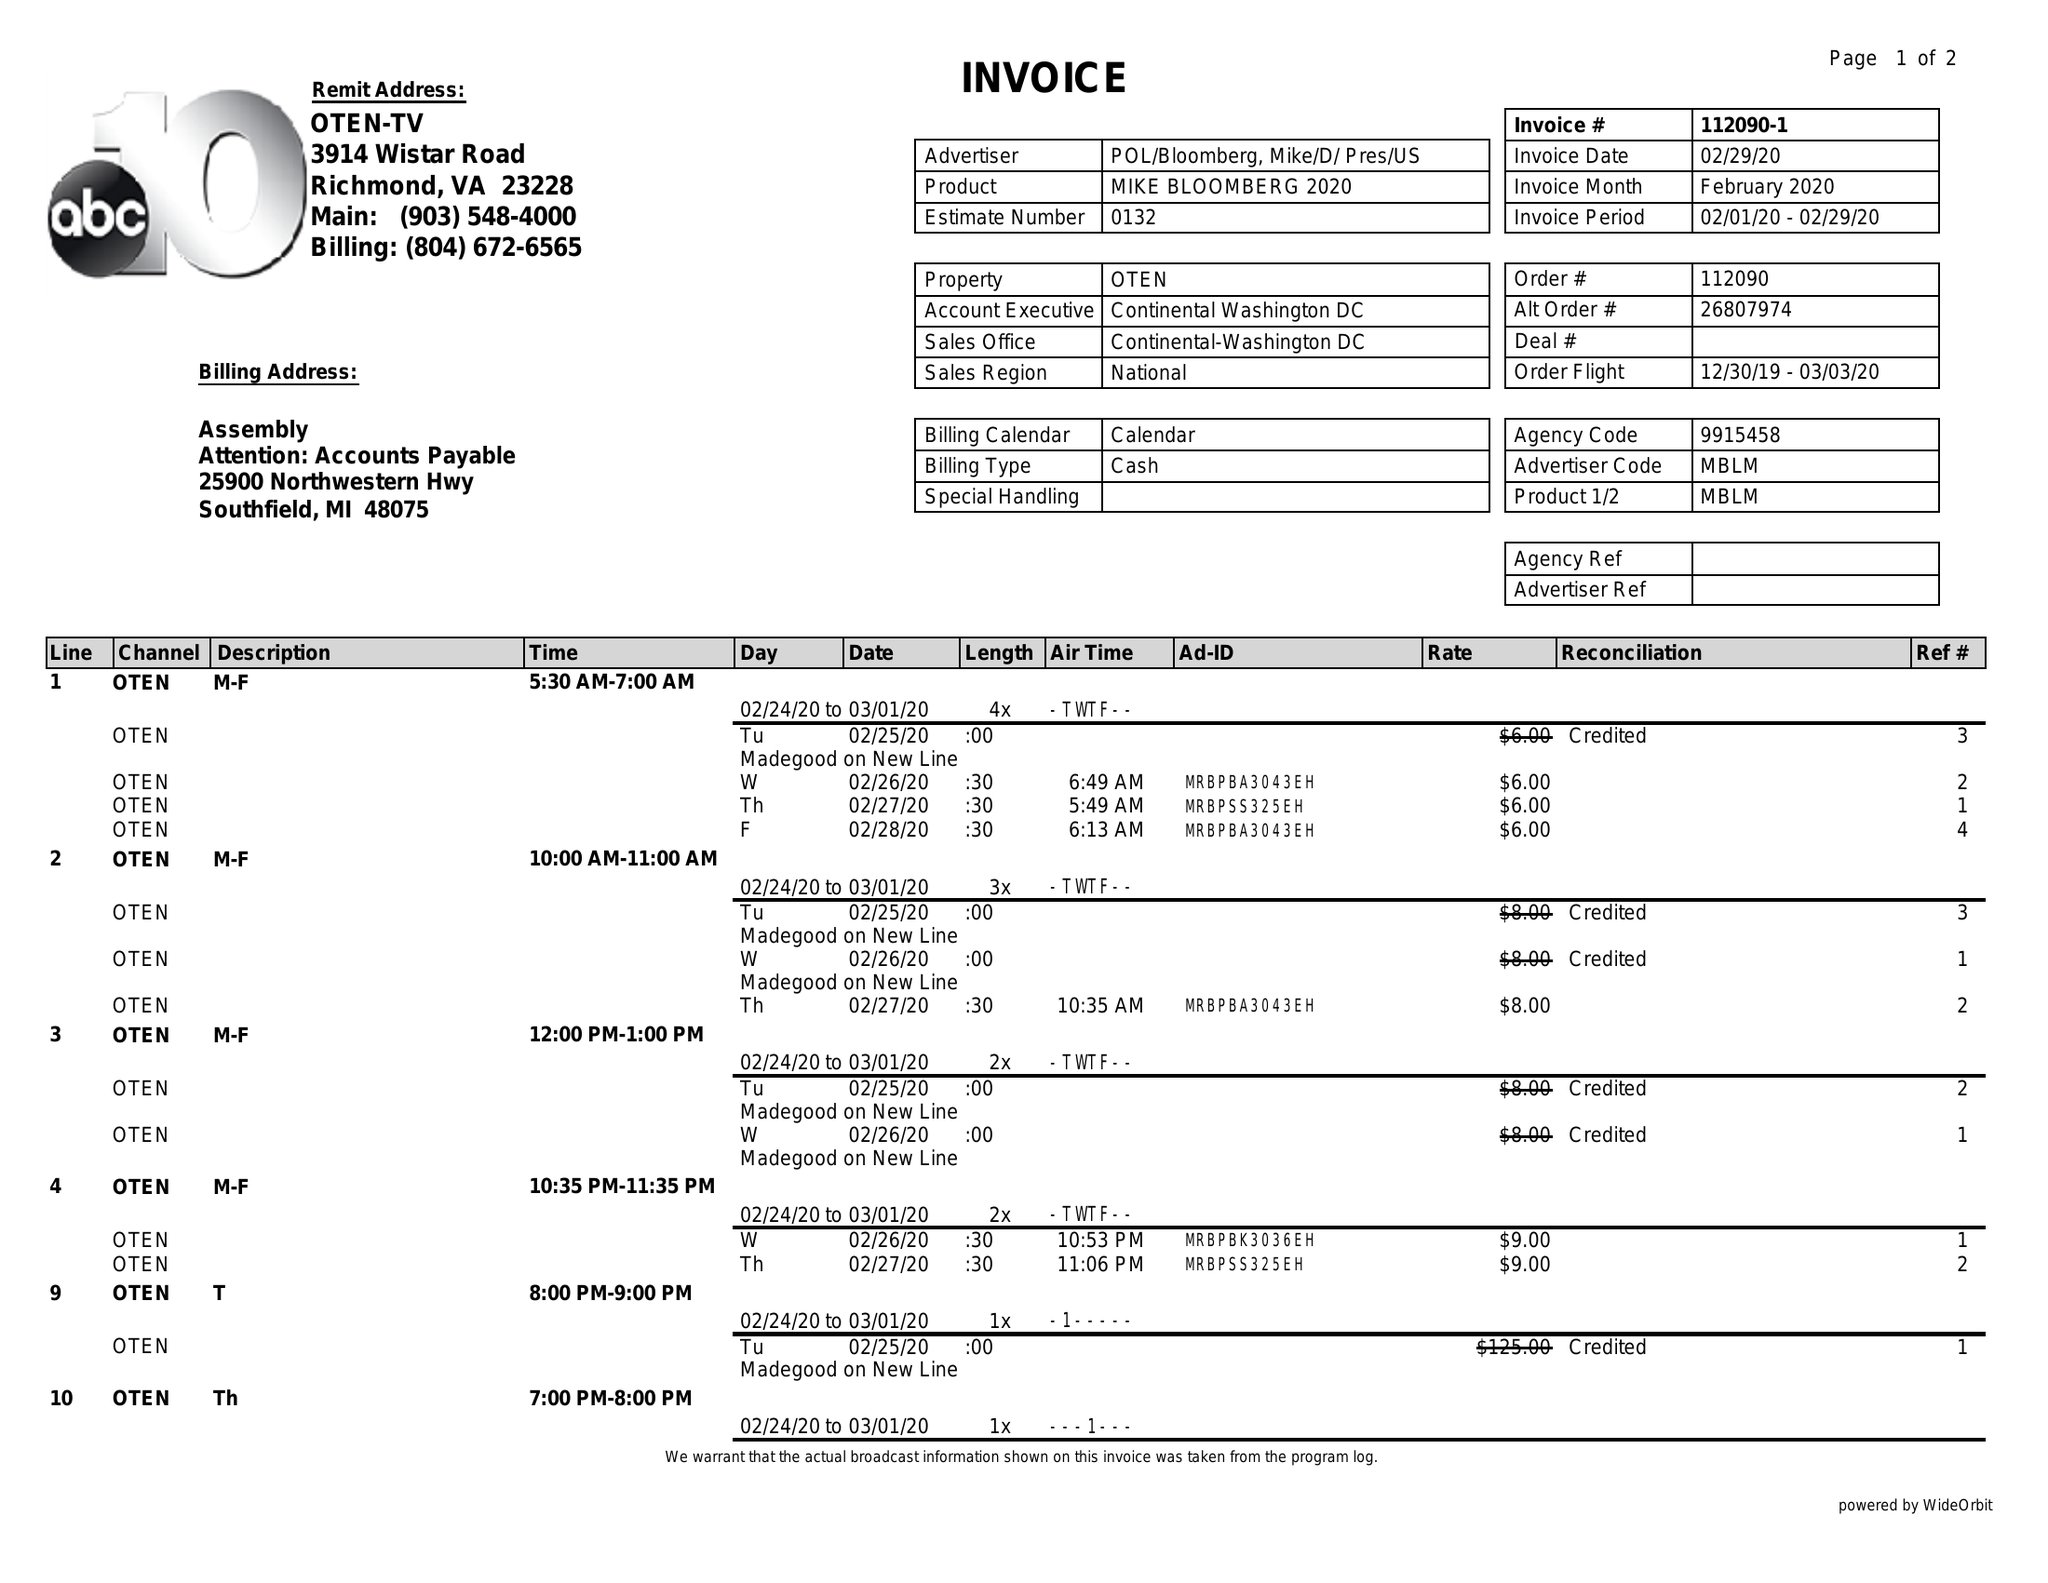What is the value for the contract_num?
Answer the question using a single word or phrase. 112090 